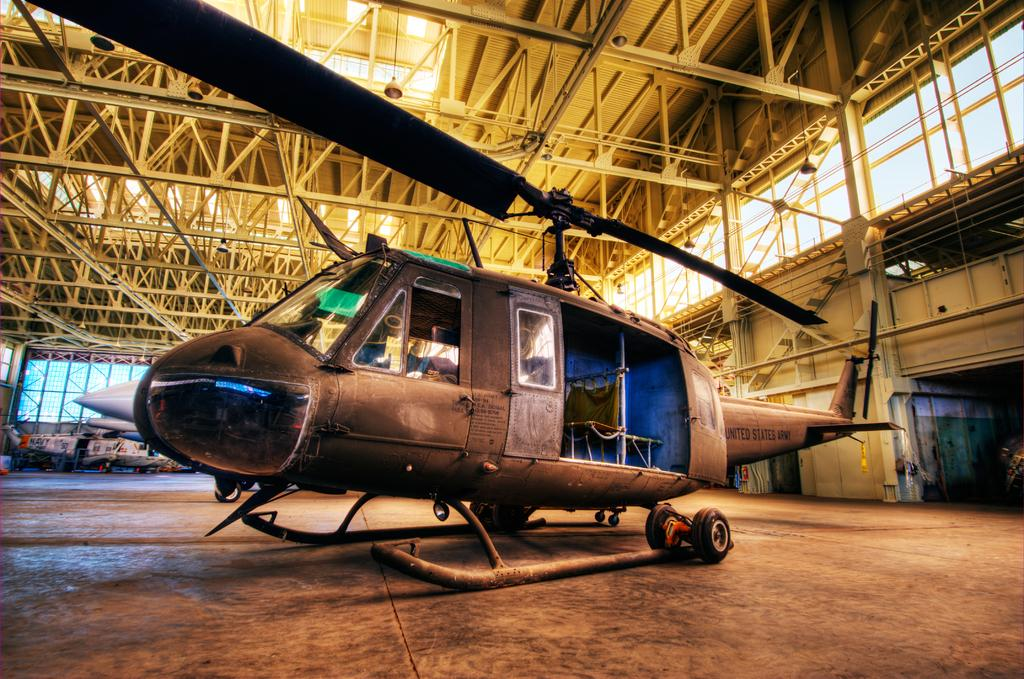What type of vehicle is the main subject in the image? There is a helicopter in the image. Are there any other vehicles present besides the helicopter? Yes, there are other vehicles in the image. Where are the vehicles located? The vehicles are in a shed. What materials can be seen in the image? There are metal rods and lights visible in the image. Can you see any tomatoes growing in the image? There are no tomatoes present in the image. Is there a ghost visible in the image? There is no ghost present in the image. 